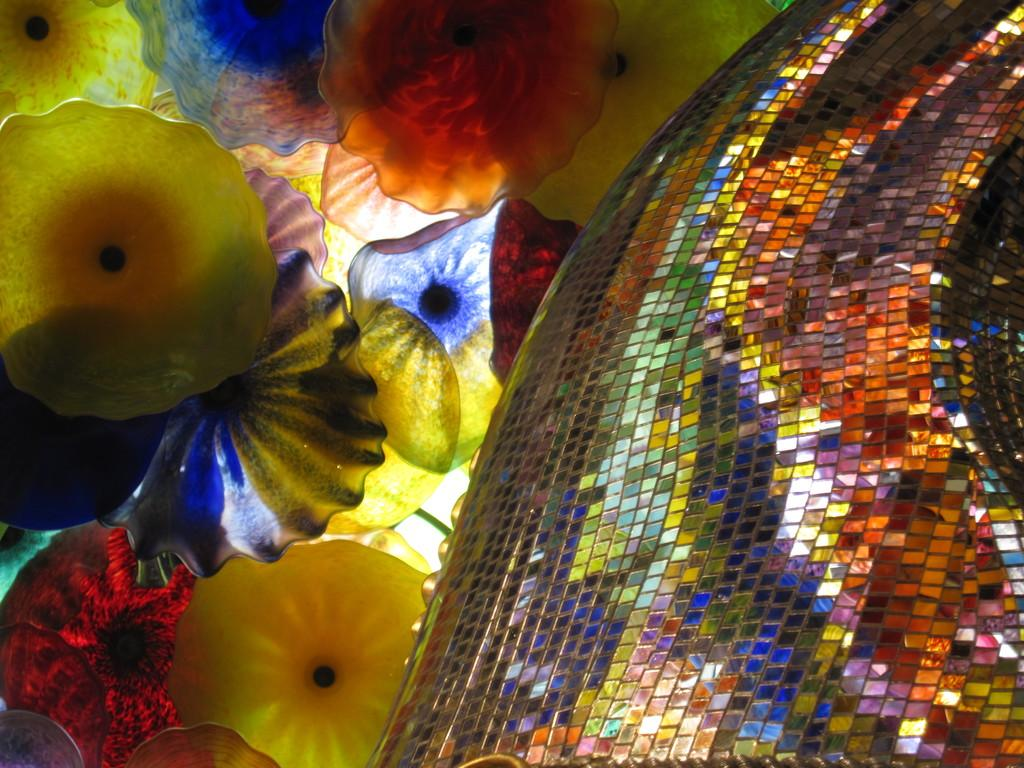What type of glasses can be seen in the image? There are colorful glasses in the image. What else is present in the image besides the glasses? There are decorative objects in the image. What type of soup is being served in the colorful glasses in the image? There is no soup present in the image; it only features colorful glasses and decorative objects. 